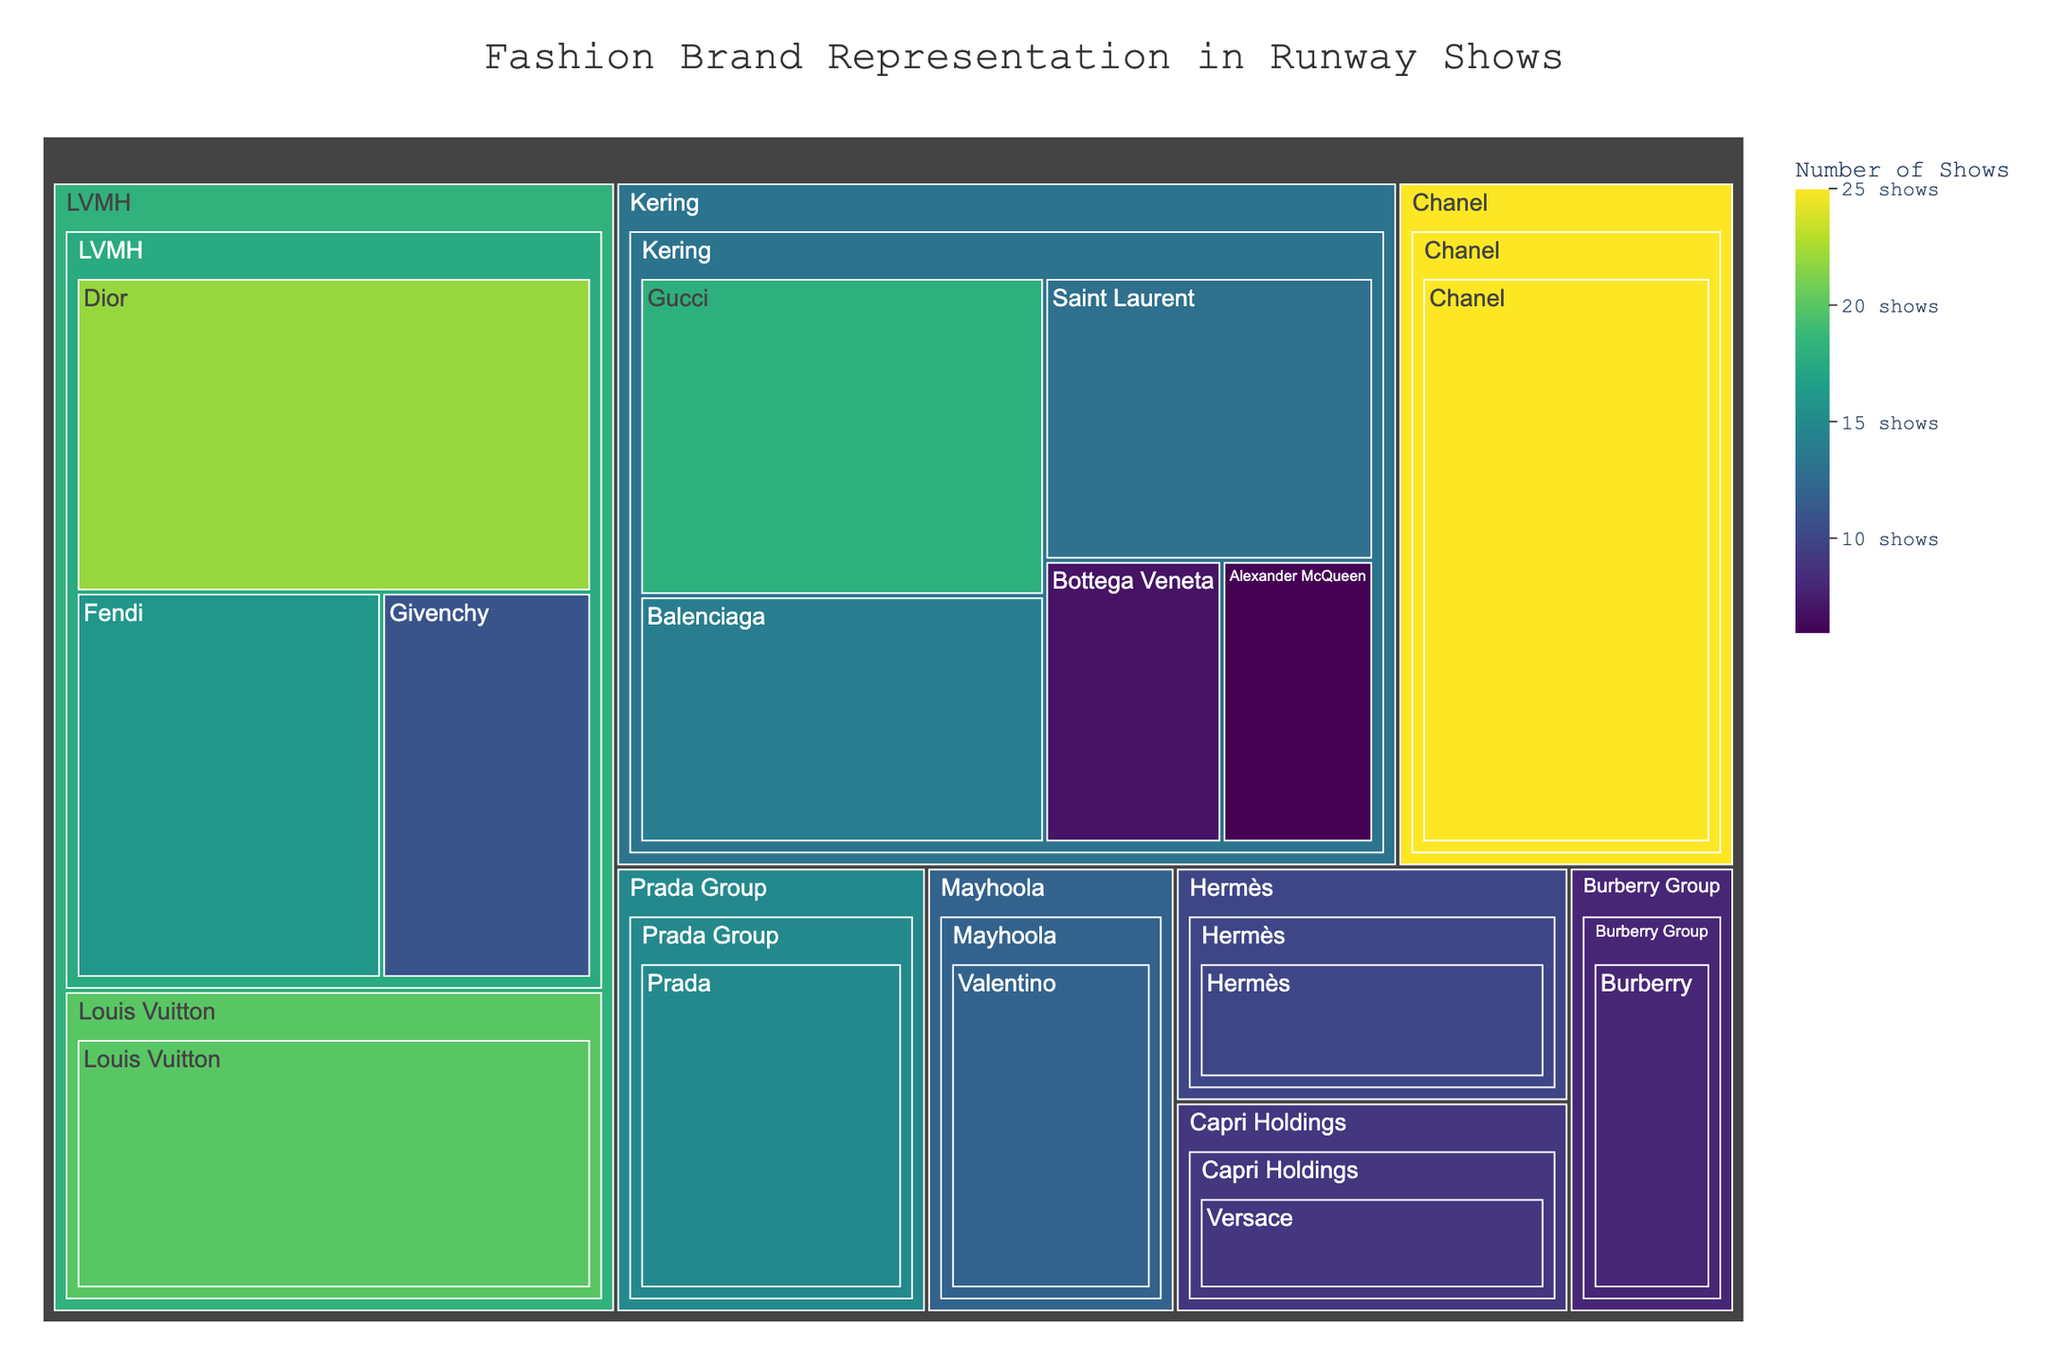what is the title of the Treemap? The title is usually displayed at the top of the chart. In this figure, the title is directly visible and states the main topic of the chart.
Answer: Fashion Brand Representation in Runway Shows Which designer has the highest number of runway shows? By looking at the size of the segments in the treemap, you can identify the designer with the largest segment. Chanel has the highest number of shows as indicated by having the largest section.
Answer: Chanel How many shows are represented by the Kering group in total? First, sum the number of shows for each designer under the Kering group: Gucci (18), Balenciaga (14), Saint Laurent (13), Bottega Veneta (7), Alexander McQueen (6). Adding these together, 18 + 14 + 13 + 7 + 6 = 58.
Answer: 58 Shows Which parent company is represented by the most runway shows? Compare the total number of shows for each parent company by summing the total number of shows represented under each parent: LVMH, Kering, Chanel, etc. LVMH would be the parent company with the most shows when all its brands' shows are added up.
Answer: LVMH How does the number of shows for Dior compare to that of Gucci? The segments for Dior and Gucci can be compared visually or by looking at the values next to each designer: Dior has 22 shows, while Gucci has 18 shows. Dior has more shows than Gucci.
Answer: Dior has more shows Which brands fall under the LVMH parent company, and how many shows do they account for together? Look at the subsegments under the LVMH parent segment in the treemap. The brands under LVMH are Louis Vuitton, Dior, Fendi, Givenchy. Sum their shows: Louis Vuitton (20), Dior (22), Fendi (16), Givenchy (11). Total: 20 + 22 + 16 + 11 = 69.
Answer: Louis Vuitton, Dior, Fendi, Givenchy account for 69 shows Are there any designers with fewer than 10 shows? If so, name them. By examining the size of the segments and the show counts, identify any designers under 10 shows. Alexander McQueen and Bottega Veneta both have fewer than 10 shows.
Answer: Alexander McQueen, Bottega Veneta What's the closest number of runway shows between Hermès and Valentino, and which has more? Hermès has 10 shows and Valentino has 12 shows. So Valentino has 2 more shows than Hermès.
Answer: Valentino has more shows by 2 Which designer has the least number of runway shows under the Kering parent company? Within the Kering section, evaluate the number of shows for each designer. Alexander McQueen has the least number of runway shows with 6.
Answer: Alexander McQueen What is the average number of shows for the top three brands? Identify the top three brands by their show counts: Chanel (25), Dior (22), Louis Vuitton (20). Calculate the average: (25 + 22 + 20)/3 = 22.33.
Answer: 22.33 shows 